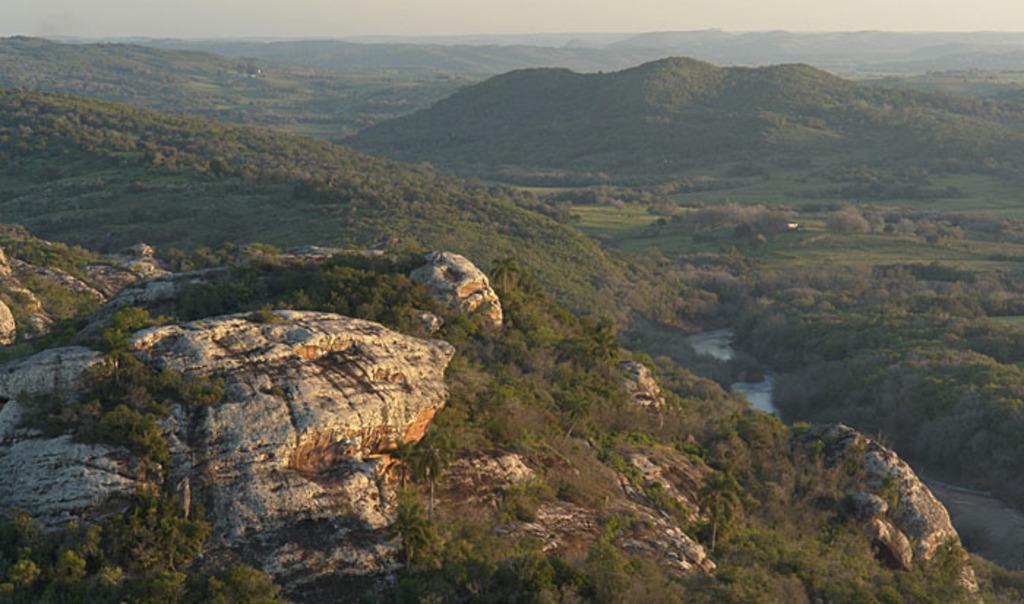Describe this image in one or two sentences. In this image I can see there is a mountain and trees on it. And there is a water and a sky. 